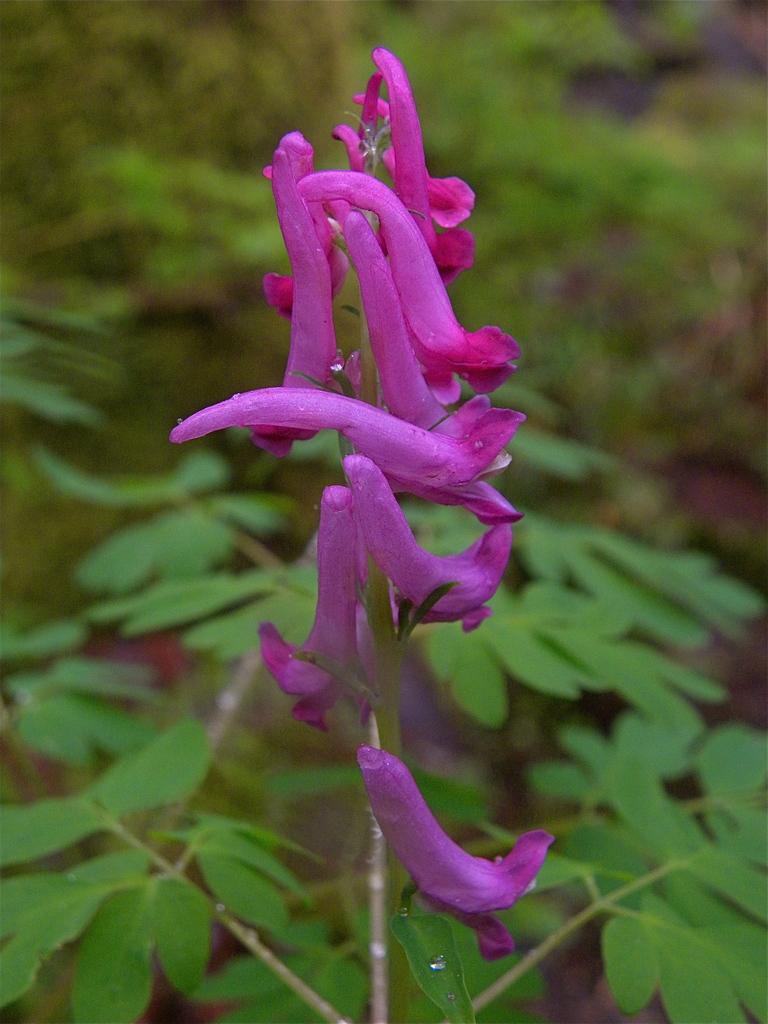How would you summarize this image in a sentence or two? In this image there are flowers, plants and trees. 